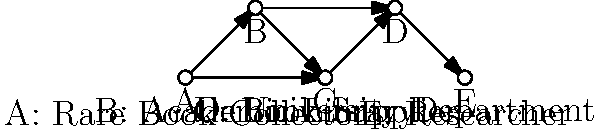In the supply chain network for rare academic texts shown above, which node represents the critical intermediary that connects rare book collectors to university departments and researchers? To determine the critical intermediary in this supply chain network for rare academic texts, let's analyze the flow of information and materials:

1. Node A represents Rare Book Collectors, who are the primary source of rare texts.
2. Node B represents Academic Libraries, which can both acquire and distribute rare texts.
3. Node C represents the Book Supplier (you), who specializes in rare and academic texts.
4. Node D represents University Departments, which require rare texts for research and teaching.
5. Node E represents individual Researchers who need access to rare academic texts.

Looking at the connections:
- Node C (Book Supplier) has incoming connections from both A (Rare Book Collectors) and B (Academic Libraries).
- Node C also has outgoing connections to D (University Departments) and indirectly to E (Researchers) through D.

This positioning makes Node C (Book Supplier) the critical intermediary in the network. It connects the sources of rare texts (collectors and libraries) to the end-users (university departments and researchers). The Book Supplier plays a crucial role in:
1. Sourcing rare texts from collectors and libraries
2. Understanding the needs of university departments and researchers
3. Facilitating the flow of rare academic texts from sources to users

Therefore, Node C, representing the Book Supplier, is the critical intermediary in this supply chain network.
Answer: C (Book Supplier) 